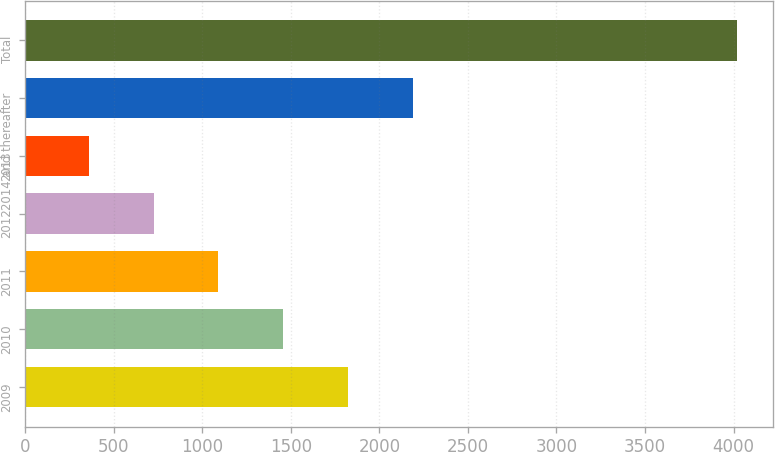Convert chart. <chart><loc_0><loc_0><loc_500><loc_500><bar_chart><fcel>2009<fcel>2010<fcel>2011<fcel>2012<fcel>2013<fcel>2014 and thereafter<fcel>Total<nl><fcel>1823.66<fcel>1457.42<fcel>1091.18<fcel>724.94<fcel>358.7<fcel>2189.9<fcel>4021.1<nl></chart> 